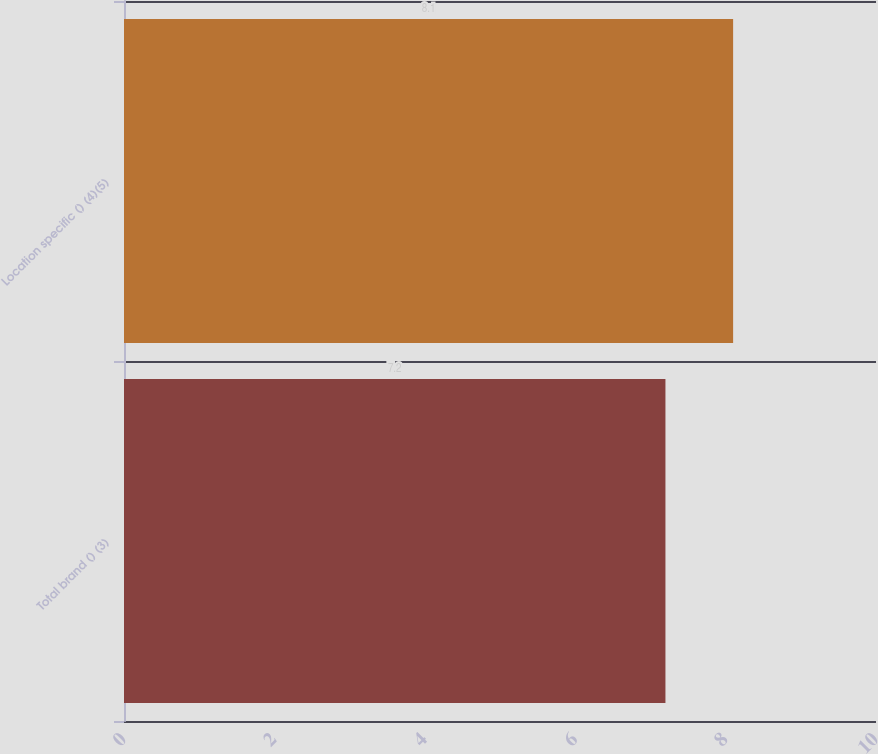<chart> <loc_0><loc_0><loc_500><loc_500><bar_chart><fcel>Total brand () (3)<fcel>Location specific () (4)(5)<nl><fcel>7.2<fcel>8.1<nl></chart> 